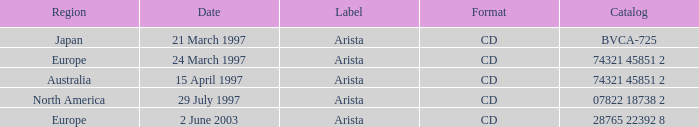On which date does the europe area have a catalog with 74321 45851 2? 24 March 1997. 